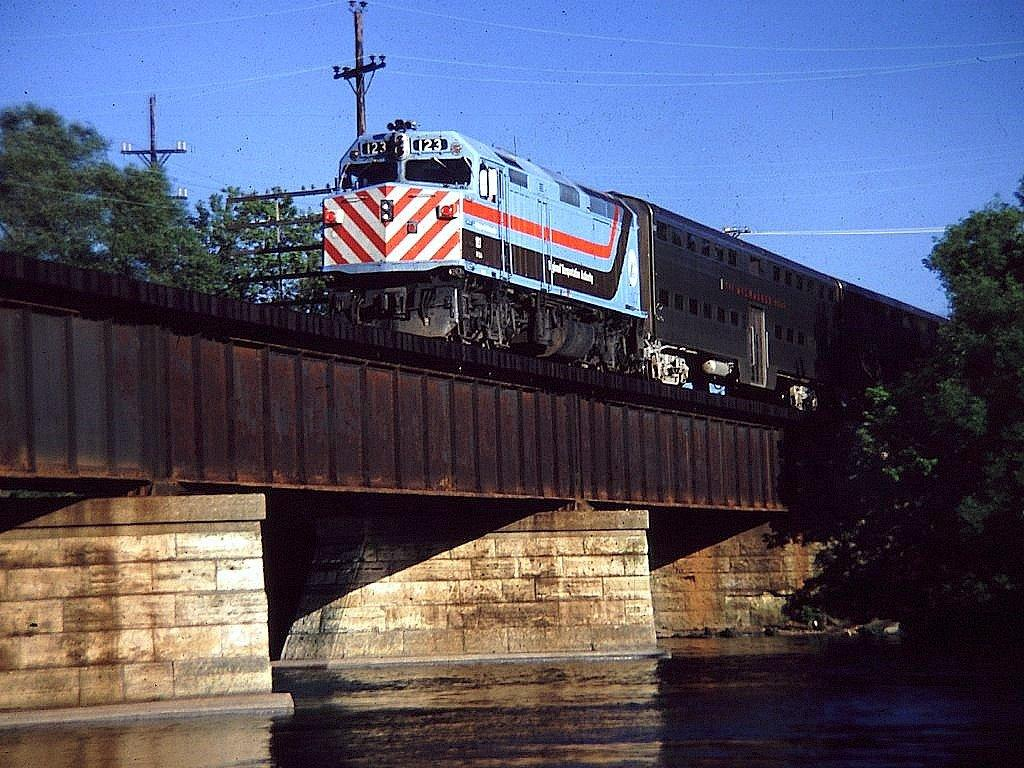What is visible in the image? Water, a train on the railway track, trees on both the left and right sides, electric poles, and the sky are visible in the image. Can you describe the train in the image? The train is on the railway track. What type of vegetation is present in the image? Trees are present on both the left and right sides of the image. What is visible at the top of the image? Electric poles and the sky are visible at the top of the image. Where is the shop located in the image? There is no shop present in the image. What type of dust can be seen on the train in the image? There is no dust visible on the train in the image. 